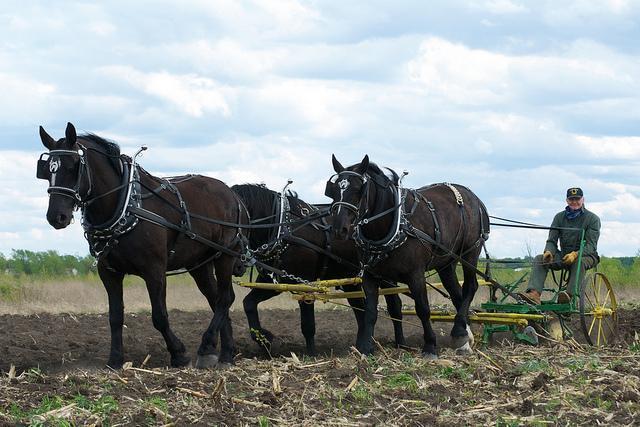How many horses are pictured?
Give a very brief answer. 3. 